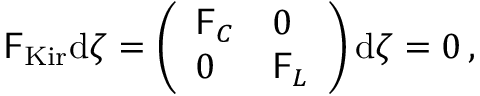Convert formula to latex. <formula><loc_0><loc_0><loc_500><loc_500>\begin{array} { r } { F _ { K i r } d \zeta = \left ( \begin{array} { l l } { F _ { C } } & { 0 } \\ { 0 } & { F _ { L } } \end{array} \right ) d \zeta = 0 \, , } \end{array}</formula> 